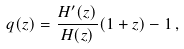<formula> <loc_0><loc_0><loc_500><loc_500>q ( z ) = \frac { H ^ { \prime } ( z ) } { H ( z ) } ( 1 + z ) - 1 \, ,</formula> 